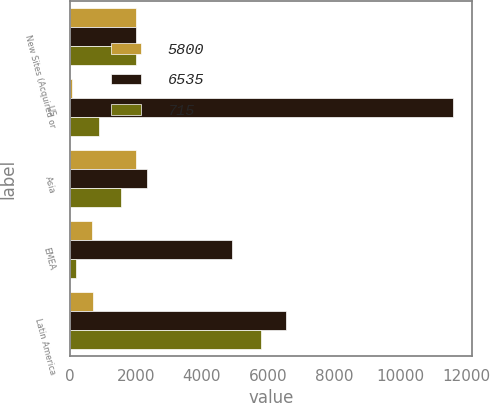<chart> <loc_0><loc_0><loc_500><loc_500><stacked_bar_chart><ecel><fcel>New Sites (Acquired or<fcel>US<fcel>Asia<fcel>EMEA<fcel>Latin America<nl><fcel>5800<fcel>2016<fcel>65<fcel>2014.5<fcel>665<fcel>715<nl><fcel>6535<fcel>2015<fcel>11595<fcel>2330<fcel>4910<fcel>6535<nl><fcel>715<fcel>2014<fcel>900<fcel>1560<fcel>190<fcel>5800<nl></chart> 